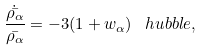Convert formula to latex. <formula><loc_0><loc_0><loc_500><loc_500>\frac { \dot { \bar { \rho _ { \alpha } } } } { \bar { \rho _ { \alpha } } } = - 3 ( 1 + w _ { \alpha } ) \, \ h u b b l e ,</formula> 